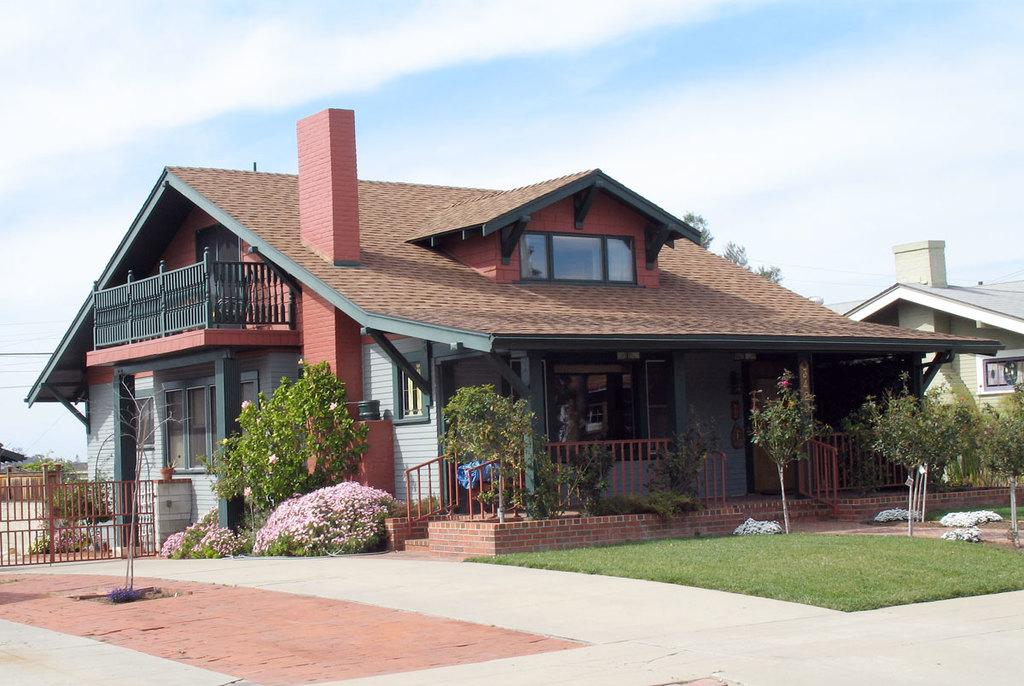What can be seen in the sky in the image? The sky with clouds is visible in the image. What type of structures are present in the image? There are buildings in the image. What architectural feature allows for vertical movement in the image? Stairs are present in the image. What safety feature is visible in the image? Railings are visible in the image. What cooking appliance is present in the image? A grill is present in the image. What type of vegetation can be seen in the image? Bushes, plants, shrubs, and trees are visible in the image. What surface is visible underfoot in the image? The floor is visible in the image. What type of spoon is being used to sing a song in the image? There is no spoon or singing in the image; it features a sky with clouds, buildings, stairs, railings, a grill, bushes, plants, shrubs, trees, and a floor. 